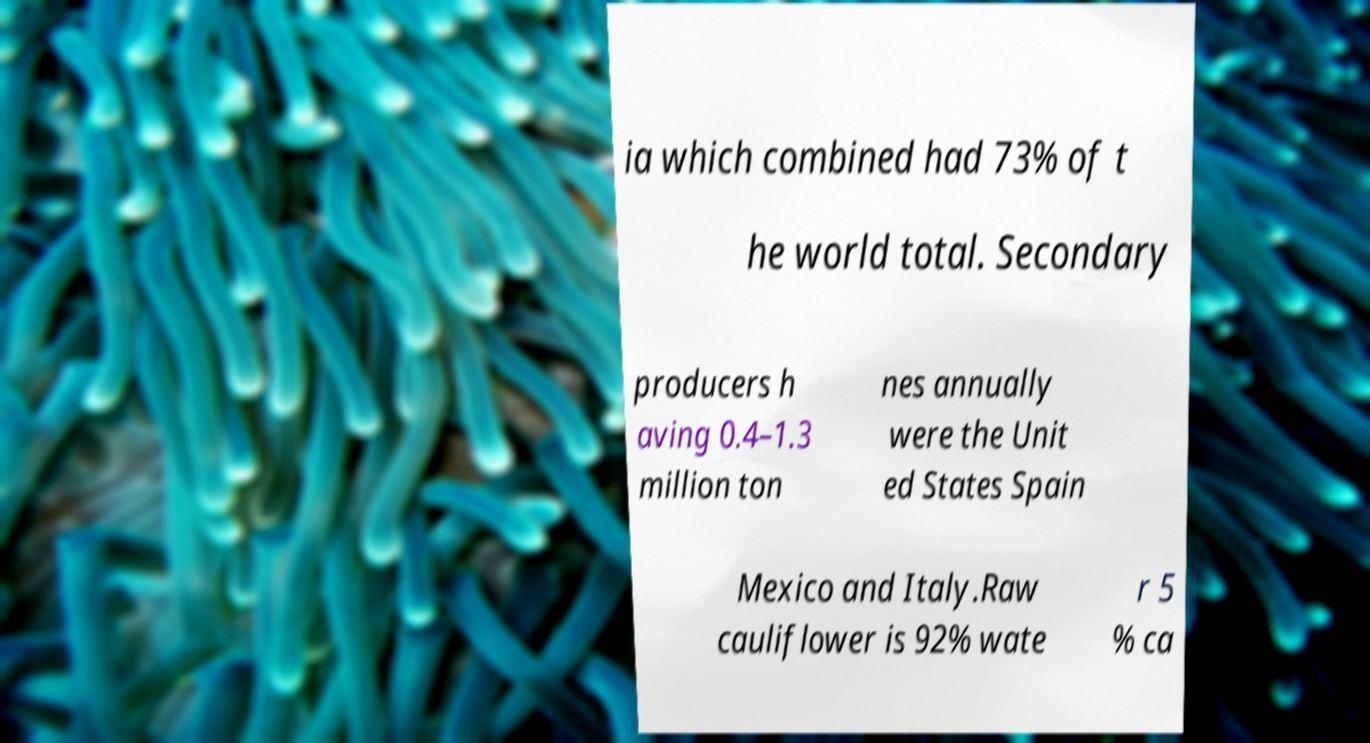Please read and relay the text visible in this image. What does it say? ia which combined had 73% of t he world total. Secondary producers h aving 0.4–1.3 million ton nes annually were the Unit ed States Spain Mexico and Italy.Raw cauliflower is 92% wate r 5 % ca 